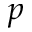<formula> <loc_0><loc_0><loc_500><loc_500>p</formula> 